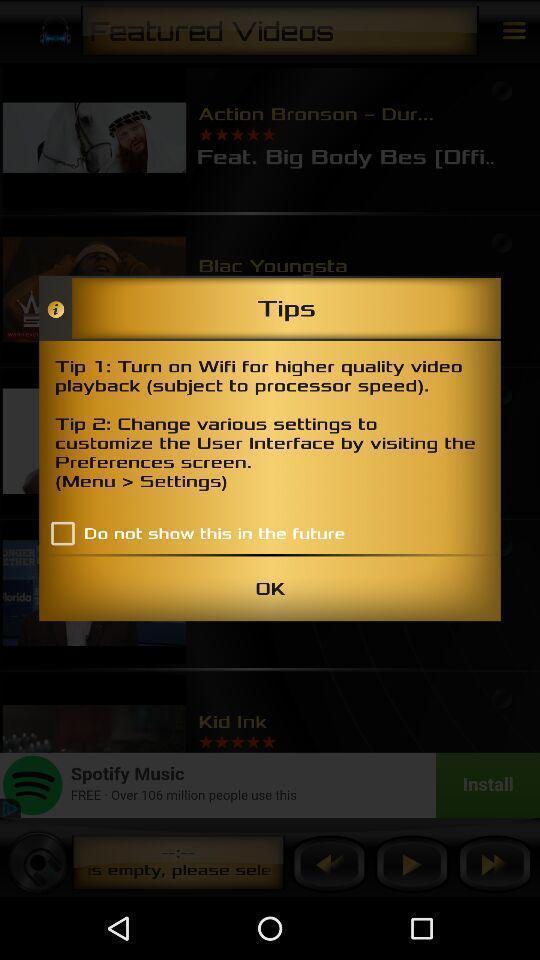Provide a description of this screenshot. Screen displaying tips for settings. 